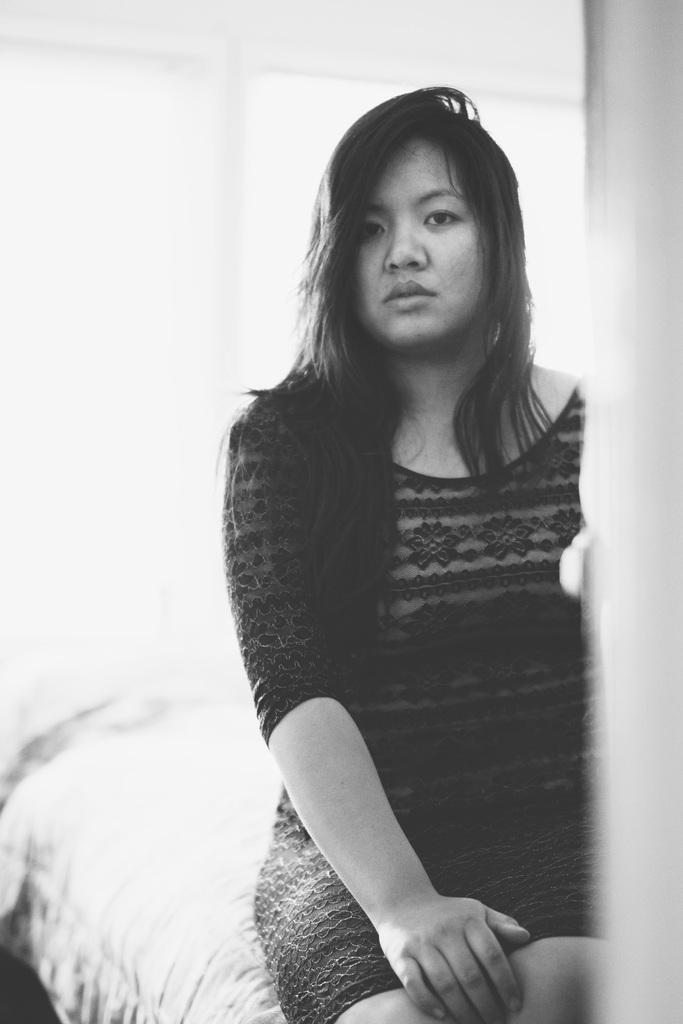What is the color scheme of the image? The image is black and white. Who or what is the main subject in the image? There is a woman in the image. What is the woman doing in the image? The woman is sitting. Where is the woman located in the image? The woman is in the middle of the image. How many ducks are sitting on the table in the image? There are no ducks present in the image, and therefore no ducks are sitting on a table. What type of thing is the woman holding in the image? The provided facts do not mention the woman holding anything, so we cannot determine what type of thing she might be holding. 